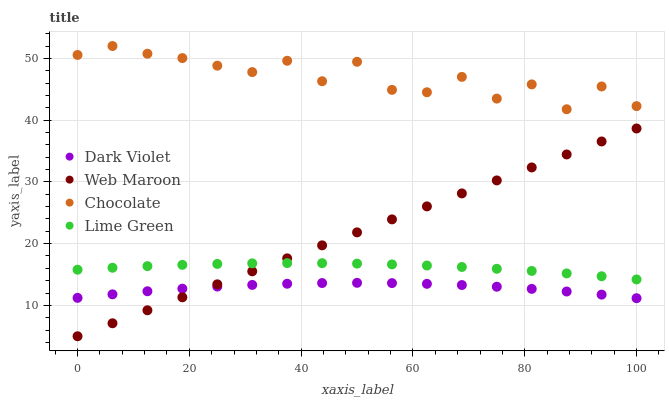Does Dark Violet have the minimum area under the curve?
Answer yes or no. Yes. Does Chocolate have the maximum area under the curve?
Answer yes or no. Yes. Does Web Maroon have the minimum area under the curve?
Answer yes or no. No. Does Web Maroon have the maximum area under the curve?
Answer yes or no. No. Is Web Maroon the smoothest?
Answer yes or no. Yes. Is Chocolate the roughest?
Answer yes or no. Yes. Is Dark Violet the smoothest?
Answer yes or no. No. Is Dark Violet the roughest?
Answer yes or no. No. Does Web Maroon have the lowest value?
Answer yes or no. Yes. Does Dark Violet have the lowest value?
Answer yes or no. No. Does Chocolate have the highest value?
Answer yes or no. Yes. Does Web Maroon have the highest value?
Answer yes or no. No. Is Web Maroon less than Chocolate?
Answer yes or no. Yes. Is Chocolate greater than Lime Green?
Answer yes or no. Yes. Does Dark Violet intersect Web Maroon?
Answer yes or no. Yes. Is Dark Violet less than Web Maroon?
Answer yes or no. No. Is Dark Violet greater than Web Maroon?
Answer yes or no. No. Does Web Maroon intersect Chocolate?
Answer yes or no. No. 